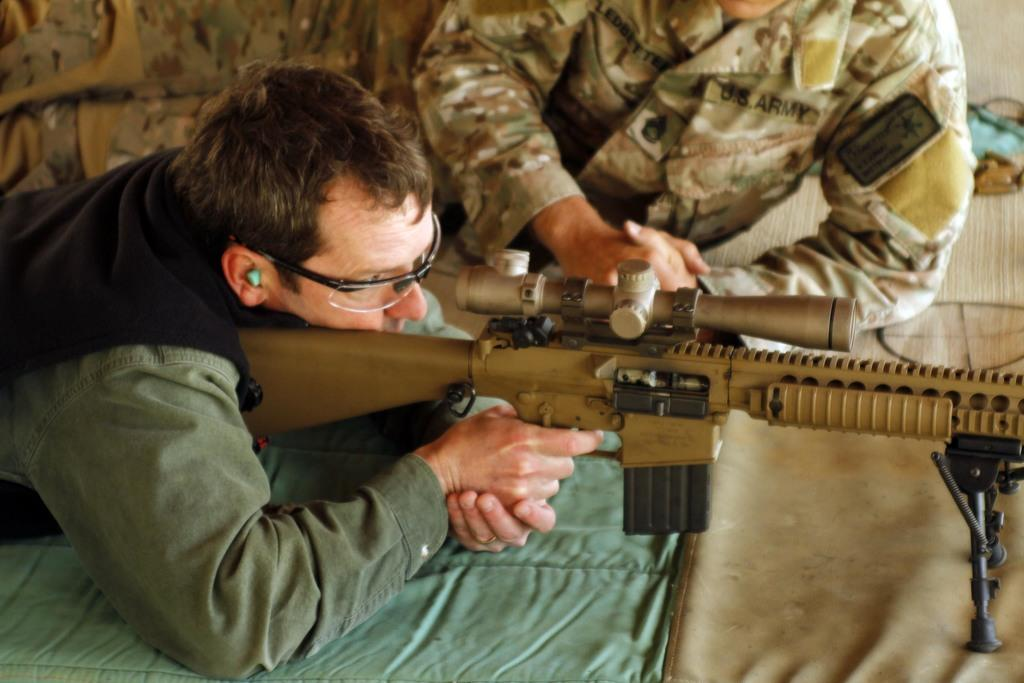What is the person in the image holding? The person in the image is holding a weapon. Can you describe the position of the second person in the image? The second person is lying behind the person with the weapon. What type of material is visible at the bottom of the image? There is cloth visible at the bottom of the image. What type of stem can be seen growing from the weapon in the image? There is no stem growing from the weapon in the image. What type of work does the person holding the weapon do for a living? There is no information about the person's occupation in the image. 